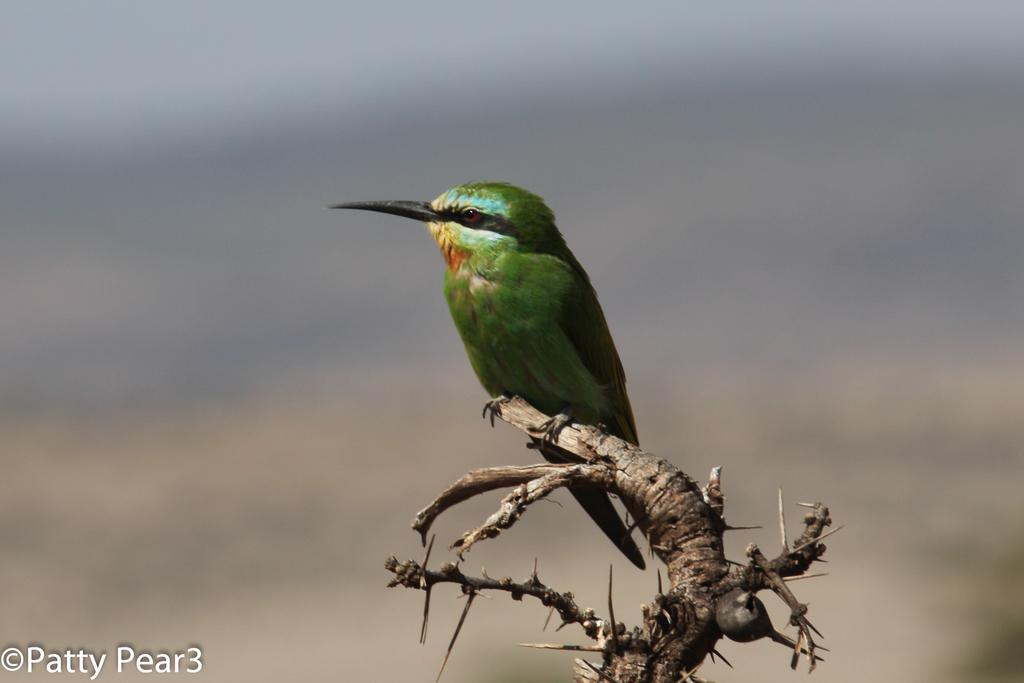What type of animal is in the image? There is a bird in the image. Where is the bird located? The bird is on a stem. Can you describe the background of the image? The background of the image is blurred. What is present in the bottom left corner of the image? There is edited text in the bottom left corner of the image. What type of insurance policy is being discussed in the image? There is no mention of insurance or any discussion in the image; it features a bird on a stem with a blurred background and edited text in the bottom left corner. 